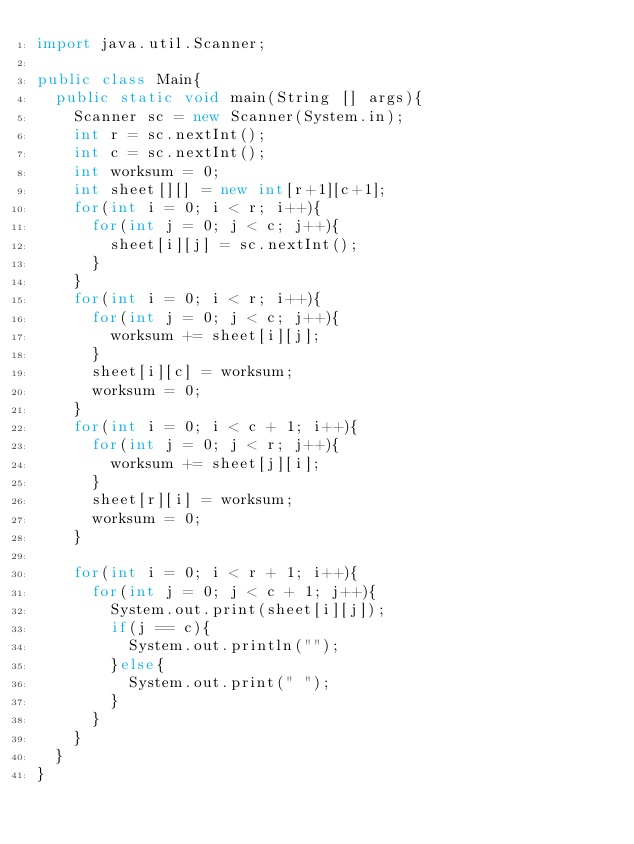<code> <loc_0><loc_0><loc_500><loc_500><_Java_>import java.util.Scanner;

public class Main{
	public static void main(String [] args){
		Scanner sc = new Scanner(System.in);
		int r = sc.nextInt();
		int c = sc.nextInt();
		int worksum = 0;
		int sheet[][] = new int[r+1][c+1];
		for(int i = 0; i < r; i++){
			for(int j = 0; j < c; j++){
				sheet[i][j] = sc.nextInt();
			}
		}
		for(int i = 0; i < r; i++){
			for(int j = 0; j < c; j++){
				worksum += sheet[i][j];
			}
			sheet[i][c] = worksum;
			worksum = 0;
		}
		for(int i = 0; i < c + 1; i++){
			for(int j = 0; j < r; j++){
				worksum += sheet[j][i];
			}
			sheet[r][i] = worksum;
			worksum = 0;
		}
		
		for(int i = 0; i < r + 1; i++){
			for(int j = 0; j < c + 1; j++){
				System.out.print(sheet[i][j]);
				if(j == c){
					System.out.println("");
				}else{
					System.out.print(" ");
				}
			}
		}
	}
}</code> 